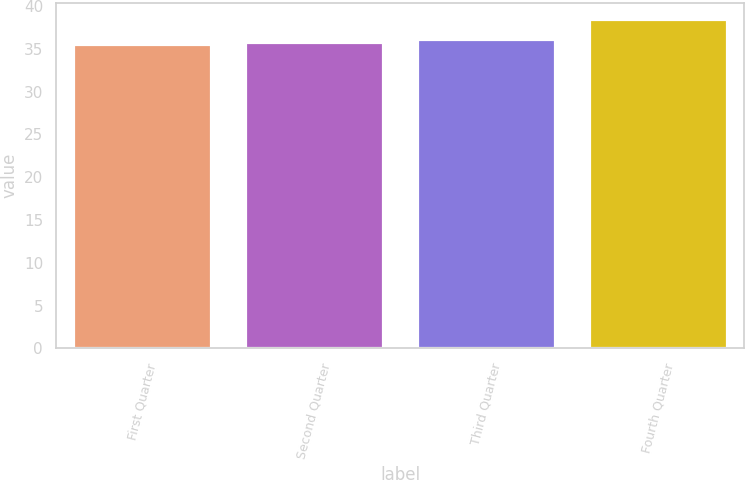Convert chart. <chart><loc_0><loc_0><loc_500><loc_500><bar_chart><fcel>First Quarter<fcel>Second Quarter<fcel>Third Quarter<fcel>Fourth Quarter<nl><fcel>35.55<fcel>35.84<fcel>36.13<fcel>38.42<nl></chart> 